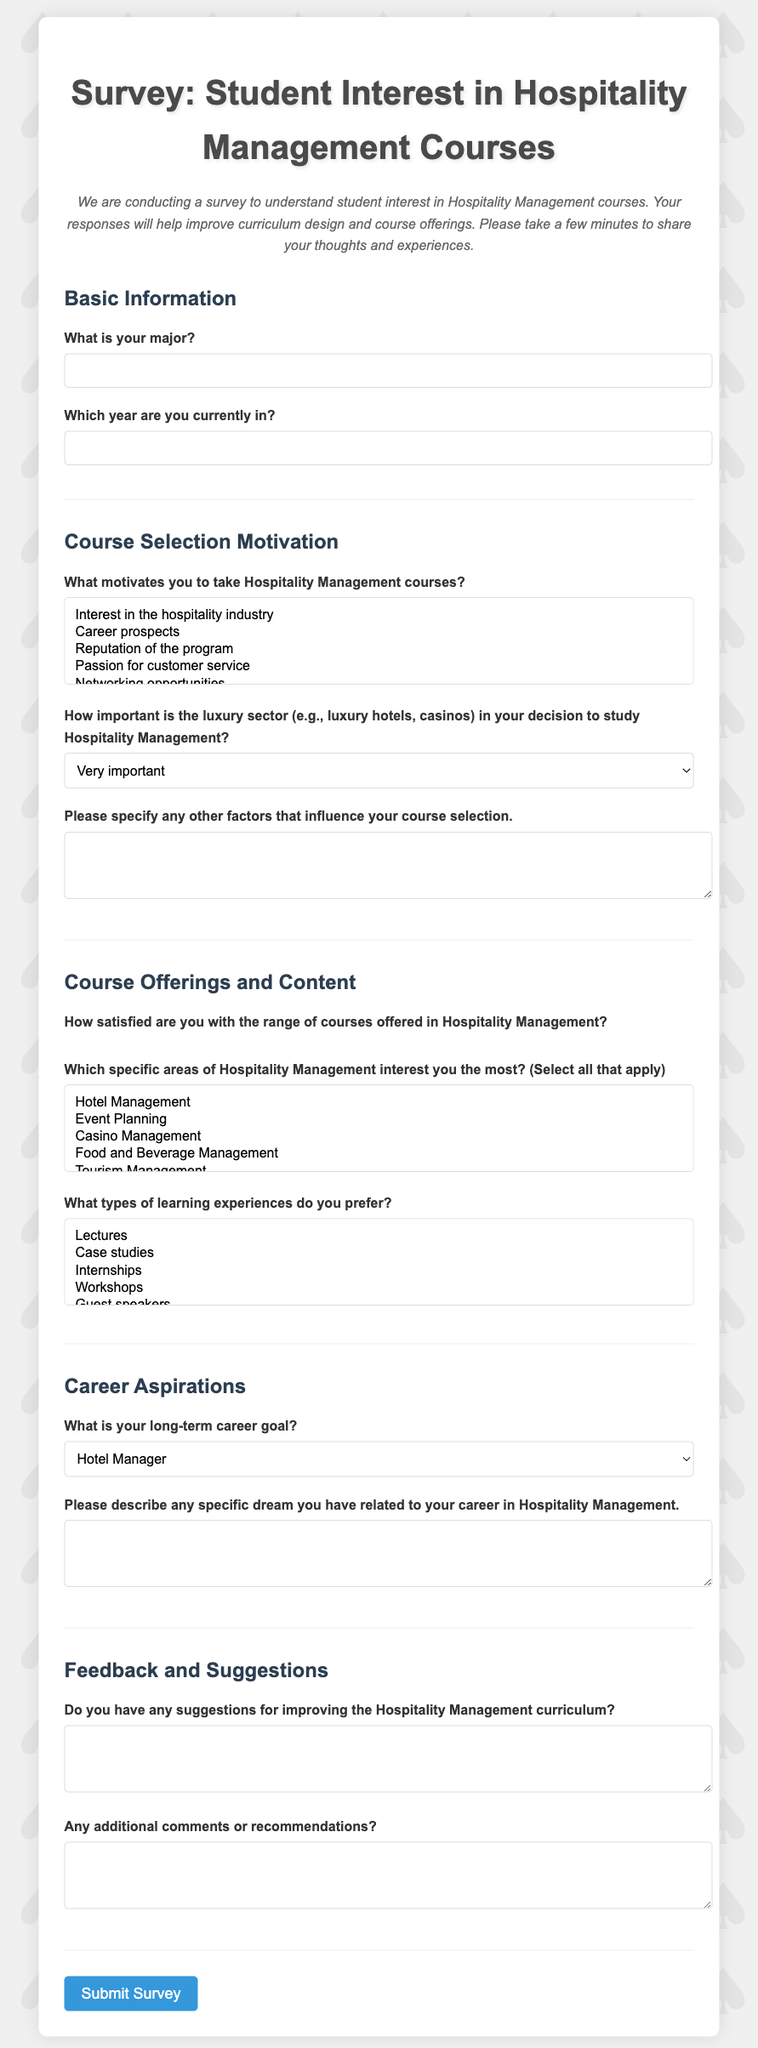What is the title of the survey? The title of the survey is prominently displayed at the top of the document.
Answer: Survey: Student Interest in Hospitality Management Courses What type of information is requested in the "Basic Information" section? This section asks for two specific pieces of information regarding the respondent's academic background.
Answer: Major and year How many options are available for motivations to take Hospitality Management courses? The number of options indicates the variety of motivations students can choose from.
Answer: Five Which luxury sector is considered very important in decision-making? The survey specifically mentions this sector in relation to students' choices in studying Hospitality Management.
Answer: Luxury hotels and casinos What is the range of satisfaction rating for the courses offered? The rating system allows respondents to express their satisfaction on a scale.
Answer: One to five stars What is the preferred long-term career goal mentioned? This question seeks to understand students' aspirations in the field of Hospitality Management.
Answer: Casino Manager What feedback is sought regarding the curriculum? The survey prompts respondents to share their suggestions for enhancing the course offerings.
Answer: Suggestions for improving the Hospitality Management curriculum How many types of learning experiences can respondents choose from? The survey lists different learning experiences that students might prefer.
Answer: Five What does the survey do upon submission? The survey provides a specific action that occurs when the form is submitted.
Answer: Alert thanking for completing the survey 